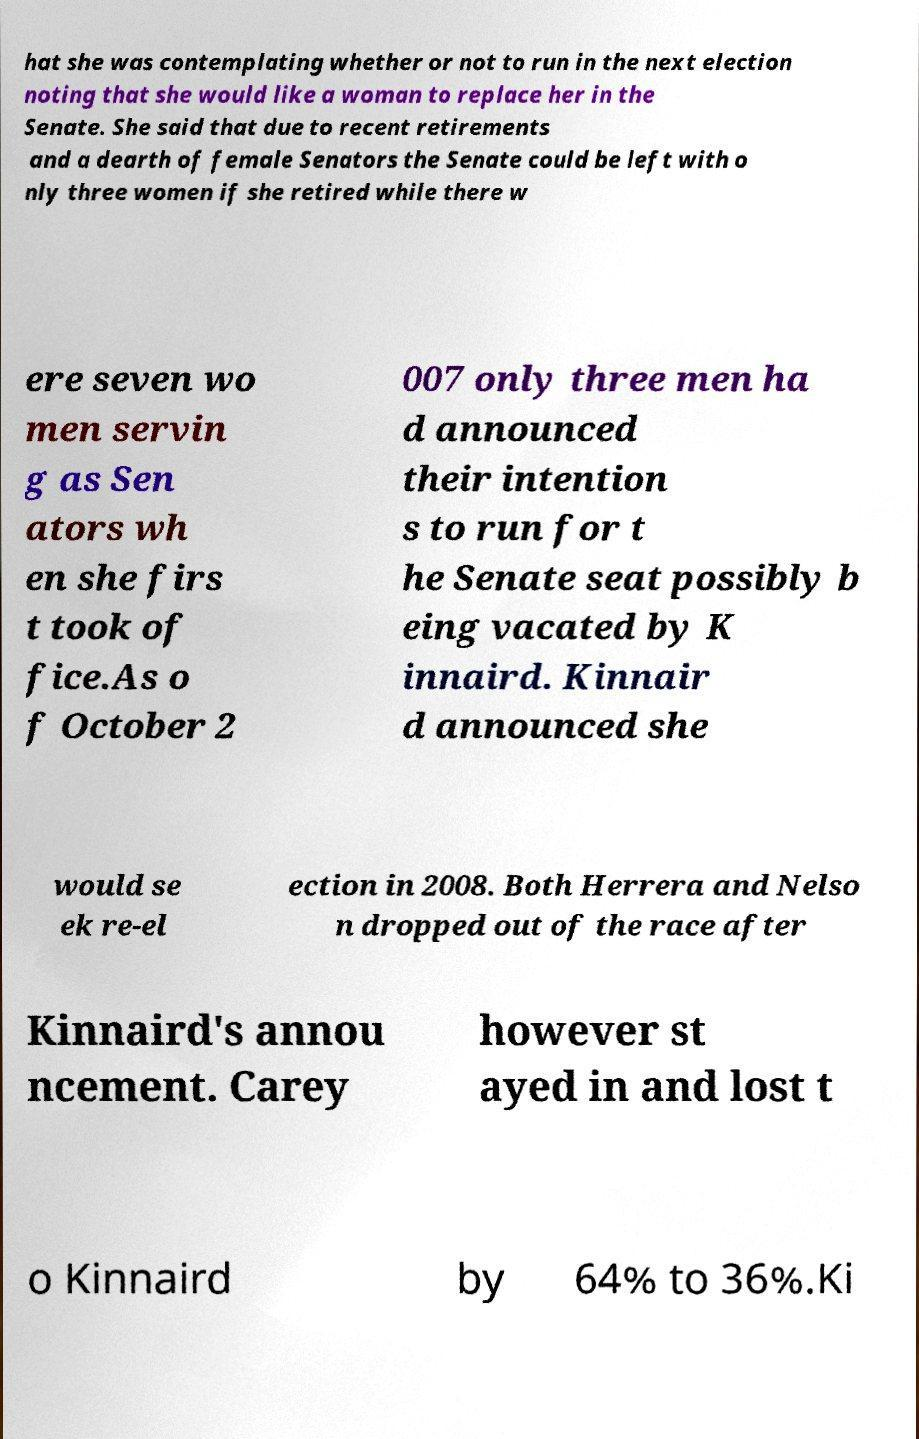I need the written content from this picture converted into text. Can you do that? hat she was contemplating whether or not to run in the next election noting that she would like a woman to replace her in the Senate. She said that due to recent retirements and a dearth of female Senators the Senate could be left with o nly three women if she retired while there w ere seven wo men servin g as Sen ators wh en she firs t took of fice.As o f October 2 007 only three men ha d announced their intention s to run for t he Senate seat possibly b eing vacated by K innaird. Kinnair d announced she would se ek re-el ection in 2008. Both Herrera and Nelso n dropped out of the race after Kinnaird's annou ncement. Carey however st ayed in and lost t o Kinnaird by 64% to 36%.Ki 